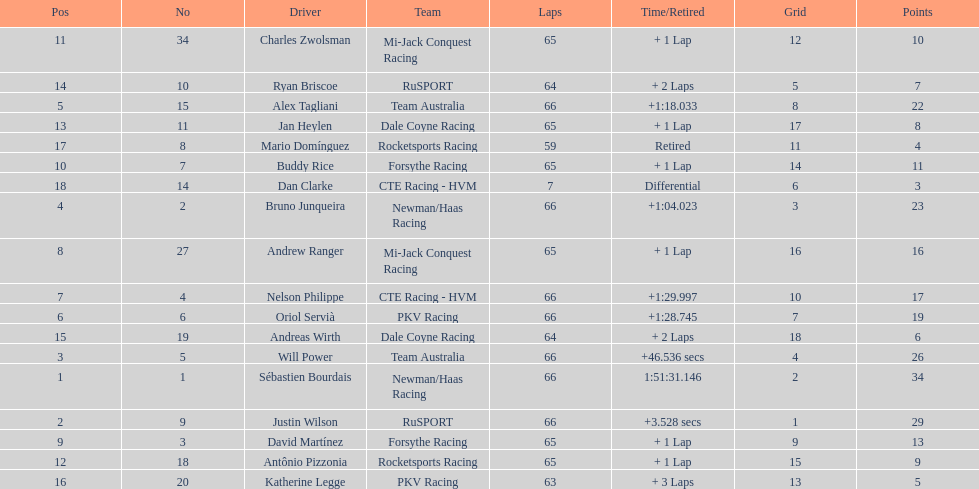At the 2006 gran premio telmex, who finished last? Dan Clarke. 